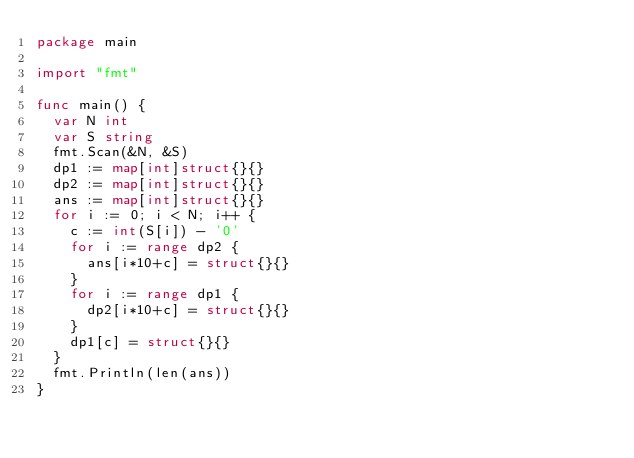Convert code to text. <code><loc_0><loc_0><loc_500><loc_500><_Go_>package main

import "fmt"

func main() {
	var N int
	var S string
	fmt.Scan(&N, &S)
	dp1 := map[int]struct{}{}
	dp2 := map[int]struct{}{}
	ans := map[int]struct{}{}
	for i := 0; i < N; i++ {
		c := int(S[i]) - '0'
		for i := range dp2 {
			ans[i*10+c] = struct{}{}
		}
		for i := range dp1 {
			dp2[i*10+c] = struct{}{}
		}
		dp1[c] = struct{}{}
	}
	fmt.Println(len(ans))
}
</code> 